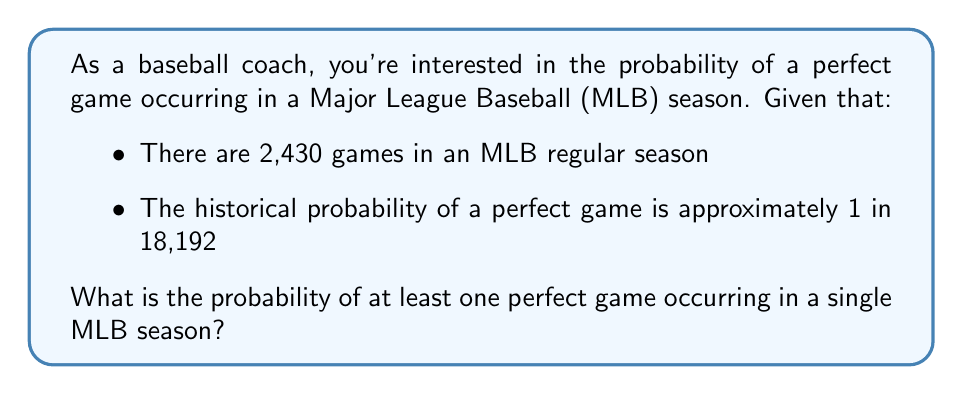Can you solve this math problem? To solve this problem, we'll use the following approach:

1) First, let's calculate the probability of a perfect game not occurring in a single game:
   $p(\text{no perfect game}) = 1 - \frac{1}{18,192} = \frac{18,191}{18,192}$

2) Now, for a perfect game to not occur in an entire season, it must not occur in any of the 2,430 games. We can calculate this probability using the multiplication rule:
   $p(\text{no perfect game in season}) = (\frac{18,191}{18,192})^{2,430}$

3) Therefore, the probability of at least one perfect game in a season is the complement of this probability:
   $p(\text{at least one perfect game}) = 1 - (\frac{18,191}{18,192})^{2,430}$

4) Let's calculate this:
   $$\begin{align*}
   p(\text{at least one perfect game}) &= 1 - (\frac{18,191}{18,192})^{2,430} \\
   &= 1 - (0.999945)^{2,430} \\
   &= 1 - 0.8743 \\
   &= 0.1257
   \end{align*}$$

5) Converting to a percentage:
   $0.1257 \times 100\% = 12.57\%$

Thus, there is approximately a 12.57% chance of at least one perfect game occurring in a single MLB season.
Answer: The probability of at least one perfect game occurring in a single MLB season is approximately 12.57%. 